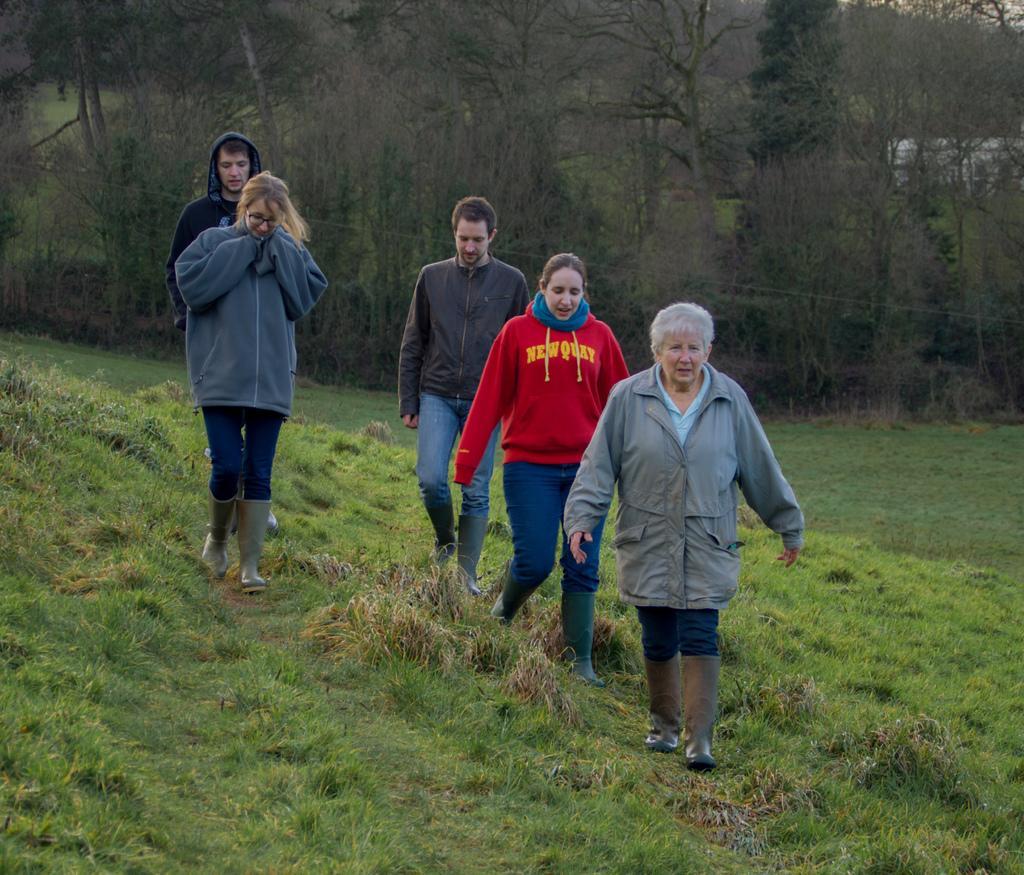Describe this image in one or two sentences. In this image I can see grass ground and on it I can see few people are standing. I can see all of them are wearing jackets and I can see one of them is wearing specs. In the background I can see number of trees and over there I can see white colour building. 